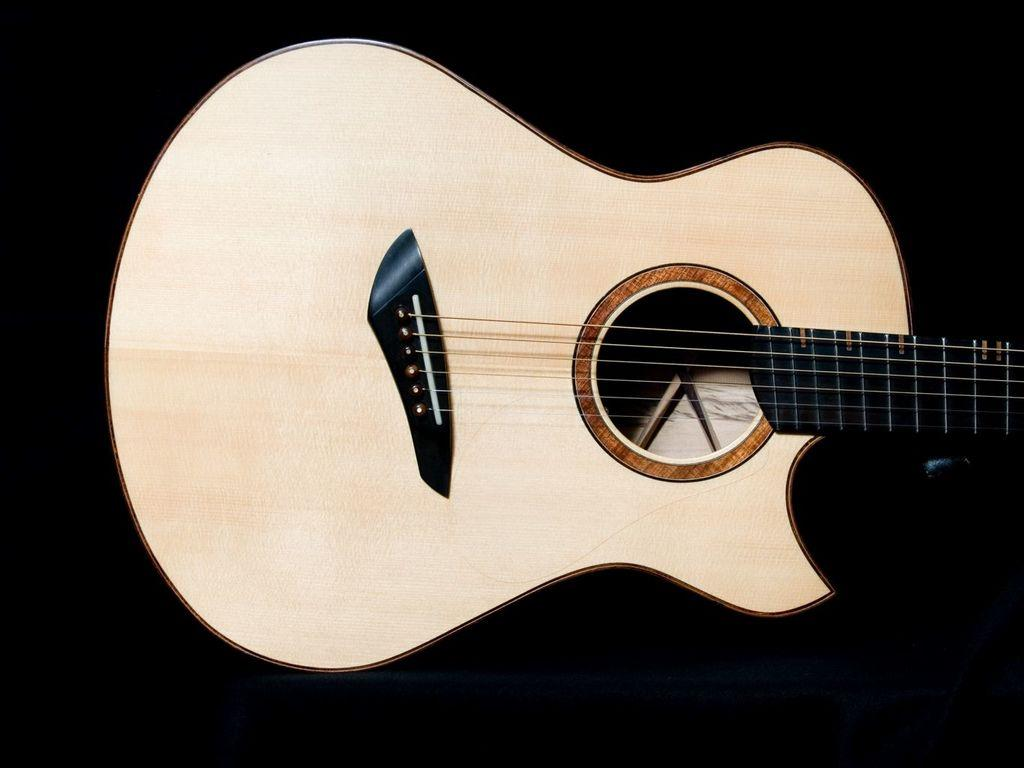What musical instrument is present in the image? There is a guitar in the image. What color is the guitar? The guitar is cream-colored. What type of ring can be seen on the guitar strings in the image? There is no ring present on the guitar strings in the image. What kind of sticks are used to play the guitar in the image? The image does not show anyone playing the guitar, so it is impossible to determine what kind of sticks might be used. 